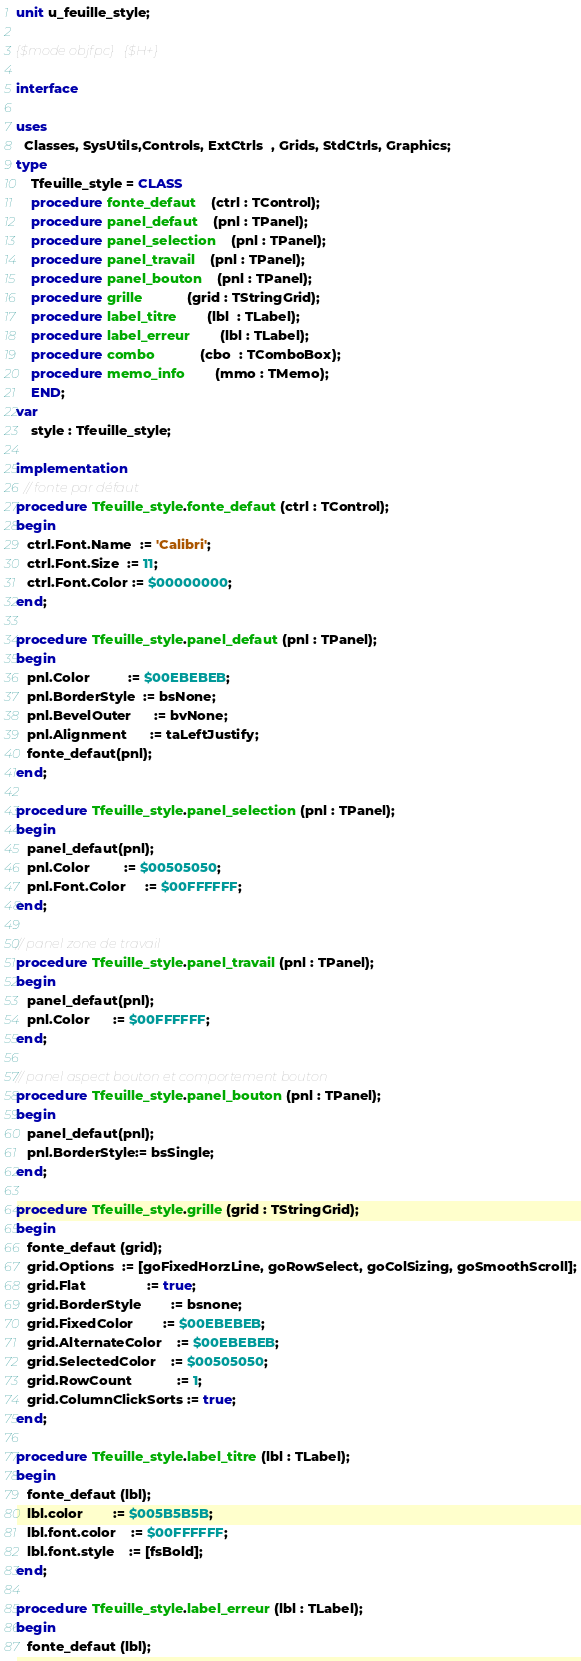Convert code to text. <code><loc_0><loc_0><loc_500><loc_500><_Pascal_>unit u_feuille_style;

{$mode objfpc}{$H+}

interface

uses
  Classes, SysUtils,Controls, ExtCtrls  , Grids, StdCtrls, Graphics;
type
	Tfeuille_style = CLASS
	procedure fonte_defaut	(ctrl : TControl);
	procedure panel_defaut	(pnl : TPanel);
	procedure panel_selection	(pnl : TPanel);
	procedure panel_travail	(pnl : TPanel);
	procedure panel_bouton	(pnl : TPanel);
	procedure grille          	(grid : TStringGrid);
	procedure label_titre     	(lbl  : TLabel);
	procedure label_erreur    	(lbl : TLabel);
	procedure combo          	(cbo  : TComboBox);
	procedure memo_info       	(mmo : TMemo);
	END;
var
	style : Tfeuille_style;

implementation
  // fonte par défaut
procedure Tfeuille_style.fonte_defaut (ctrl : TControl);
begin
   ctrl.Font.Name  := 'Calibri';
   ctrl.Font.Size  := 11;
   ctrl.Font.Color := $00000000;
end;

procedure Tfeuille_style.panel_defaut (pnl : TPanel);
begin
   pnl.Color     	  := $00EBEBEB;
   pnl.BorderStyle  := bsNone;
   pnl.BevelOuter	  := bvNone;
   pnl.Alignment 	  := taLeftJustify;
   fonte_defaut(pnl);
end;

procedure Tfeuille_style.panel_selection (pnl : TPanel);
begin
   panel_defaut(pnl);
   pnl.Color     	 := $00505050;
   pnl.Font.Color 	 := $00FFFFFF;
end;

// panel zone de travail
procedure Tfeuille_style.panel_travail (pnl : TPanel);
begin
   panel_defaut(pnl);
   pnl.Color      := $00FFFFFF;
end;

// panel aspect bouton et comportement bouton
procedure Tfeuille_style.panel_bouton (pnl : TPanel);
begin
   panel_defaut(pnl);
   pnl.BorderStyle:= bsSingle;
end;

procedure Tfeuille_style.grille (grid : TStringGrid);
begin
   fonte_defaut (grid);
   grid.Options  := [goFixedHorzLine, goRowSelect, goColSizing, goSmoothScroll];
   grid.Flat            	:= true;
   grid.BorderStyle     	:= bsnone;
   grid.FixedColor      	:= $00EBEBEB;
   grid.AlternateColor  	:= $00EBEBEB;
   grid.SelectedColor   	:= $00505050;
   grid.RowCount         	:= 1;
   grid.ColumnClickSorts := true;
end;

procedure Tfeuille_style.label_titre (lbl : TLabel);
begin
   fonte_defaut (lbl);
   lbl.color      	:= $005B5B5B;
   lbl.font.color 	:= $00FFFFFF;
   lbl.font.style 	:= [fsBold];
end;

procedure Tfeuille_style.label_erreur (lbl : TLabel);
begin
   fonte_defaut (lbl);</code> 